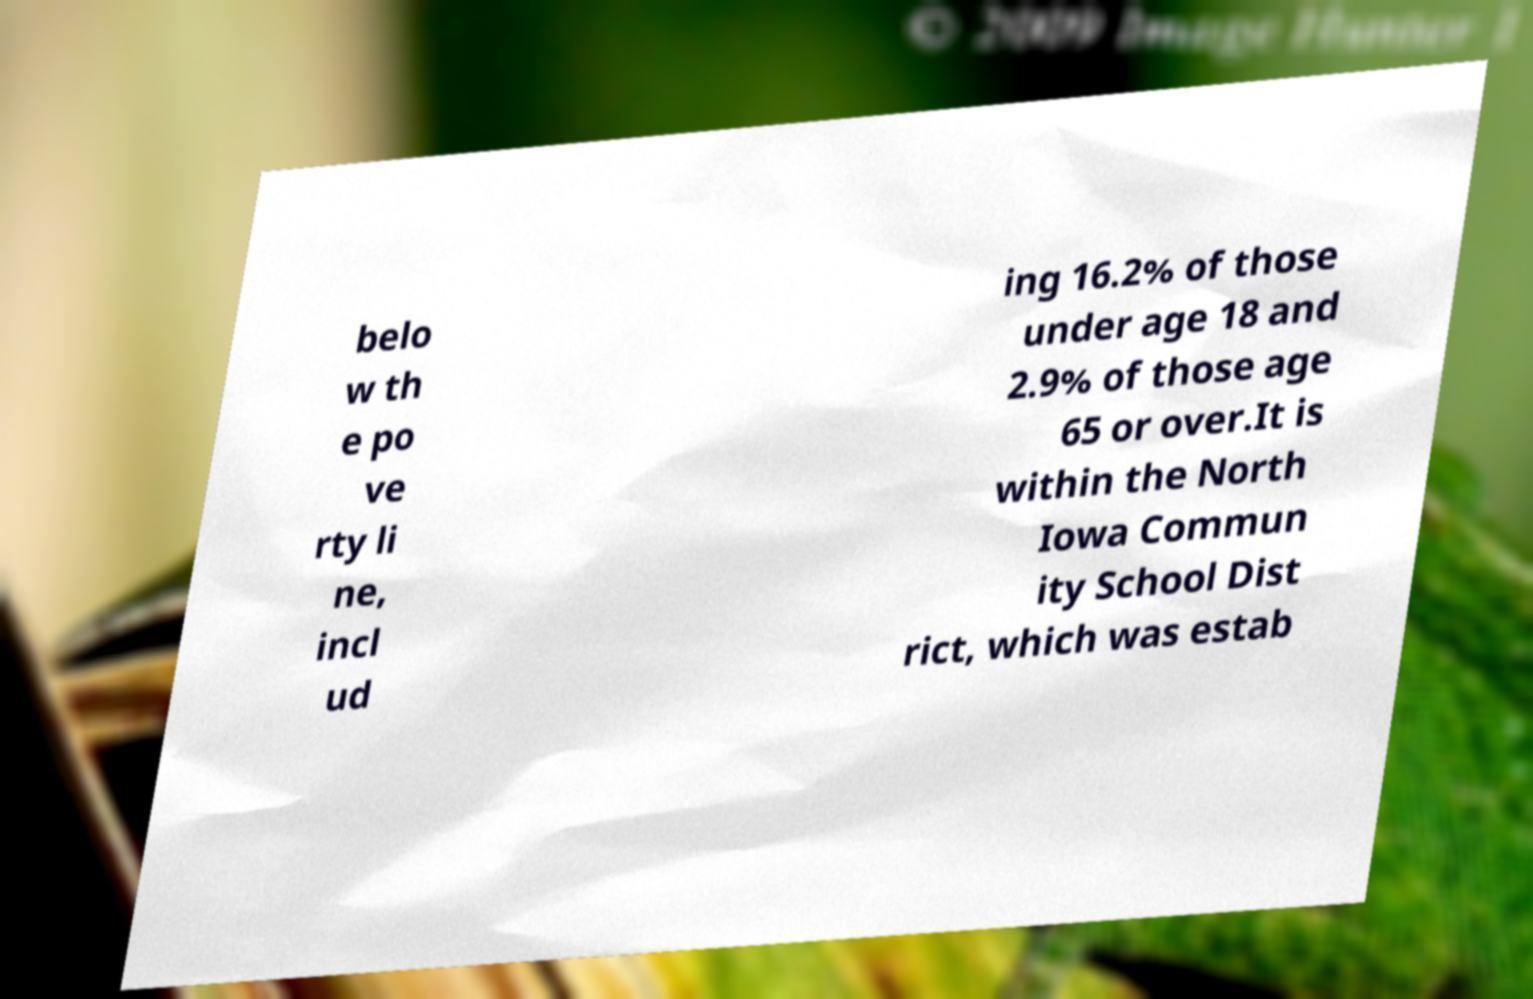Please identify and transcribe the text found in this image. belo w th e po ve rty li ne, incl ud ing 16.2% of those under age 18 and 2.9% of those age 65 or over.It is within the North Iowa Commun ity School Dist rict, which was estab 